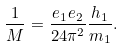<formula> <loc_0><loc_0><loc_500><loc_500>\frac { 1 } { M } = \frac { e _ { 1 } e _ { 2 } } { 2 4 \pi ^ { 2 } } \frac { h _ { 1 } } { m _ { 1 } } .</formula> 